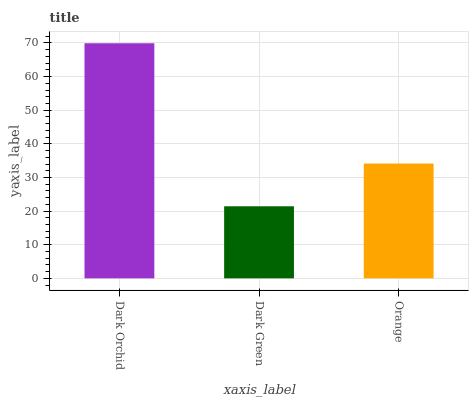Is Dark Green the minimum?
Answer yes or no. Yes. Is Dark Orchid the maximum?
Answer yes or no. Yes. Is Orange the minimum?
Answer yes or no. No. Is Orange the maximum?
Answer yes or no. No. Is Orange greater than Dark Green?
Answer yes or no. Yes. Is Dark Green less than Orange?
Answer yes or no. Yes. Is Dark Green greater than Orange?
Answer yes or no. No. Is Orange less than Dark Green?
Answer yes or no. No. Is Orange the high median?
Answer yes or no. Yes. Is Orange the low median?
Answer yes or no. Yes. Is Dark Green the high median?
Answer yes or no. No. Is Dark Orchid the low median?
Answer yes or no. No. 